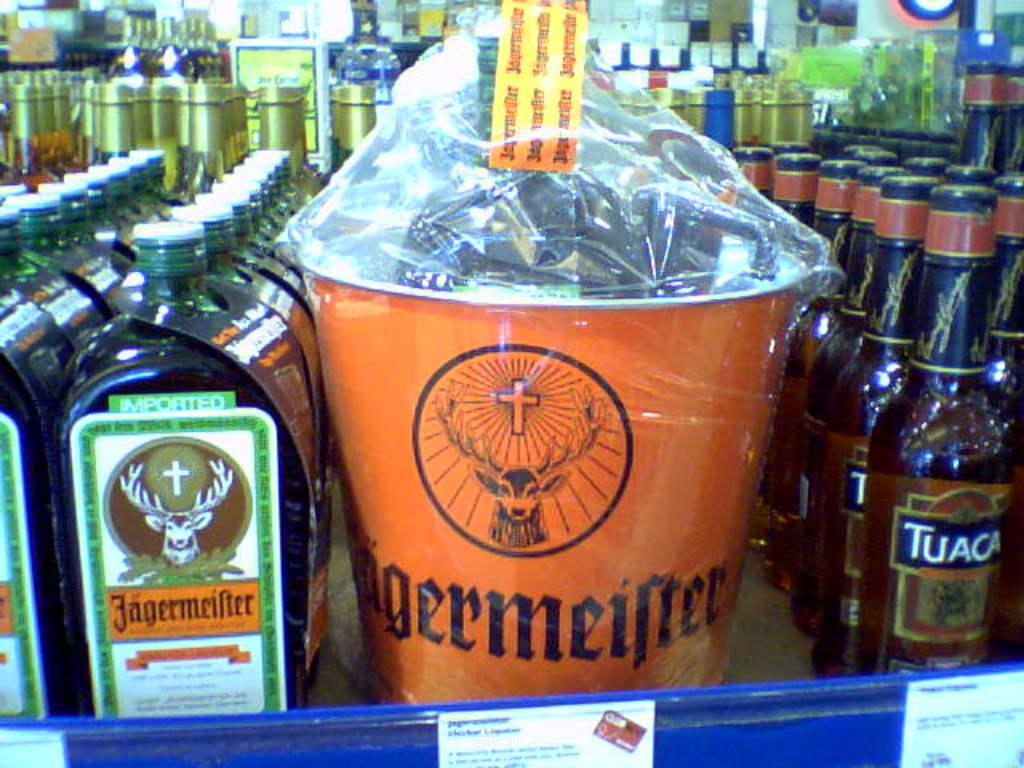What type of fantastic liquor is shown here?
Keep it short and to the point. Jagermeister. What is the name of the liquor to the right?
Give a very brief answer. Tuaca. 